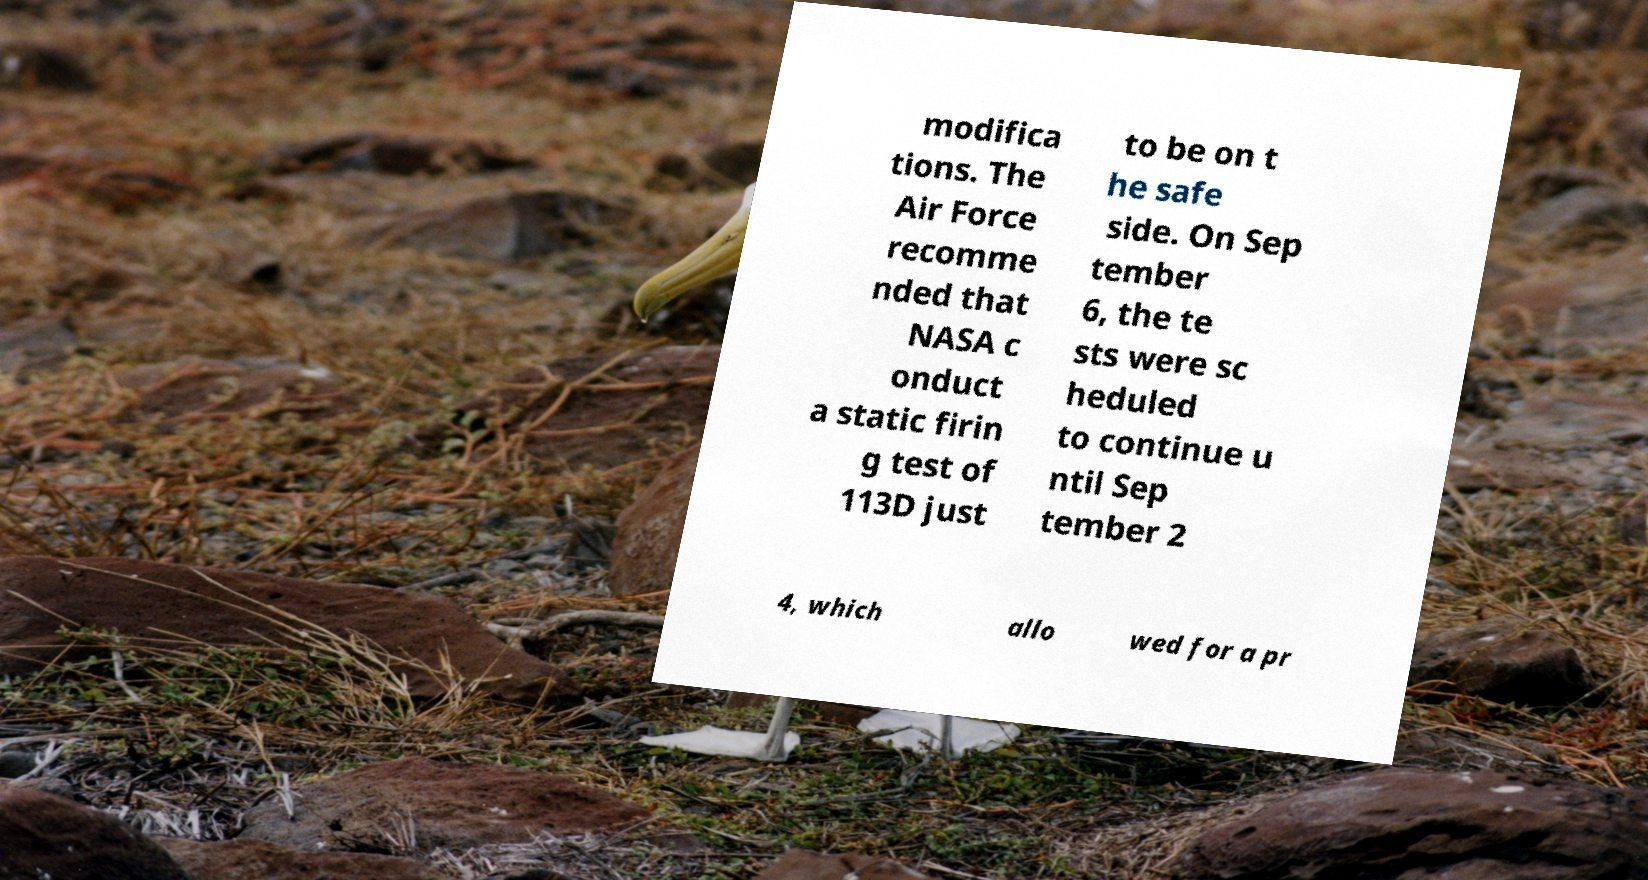Can you read and provide the text displayed in the image?This photo seems to have some interesting text. Can you extract and type it out for me? modifica tions. The Air Force recomme nded that NASA c onduct a static firin g test of 113D just to be on t he safe side. On Sep tember 6, the te sts were sc heduled to continue u ntil Sep tember 2 4, which allo wed for a pr 